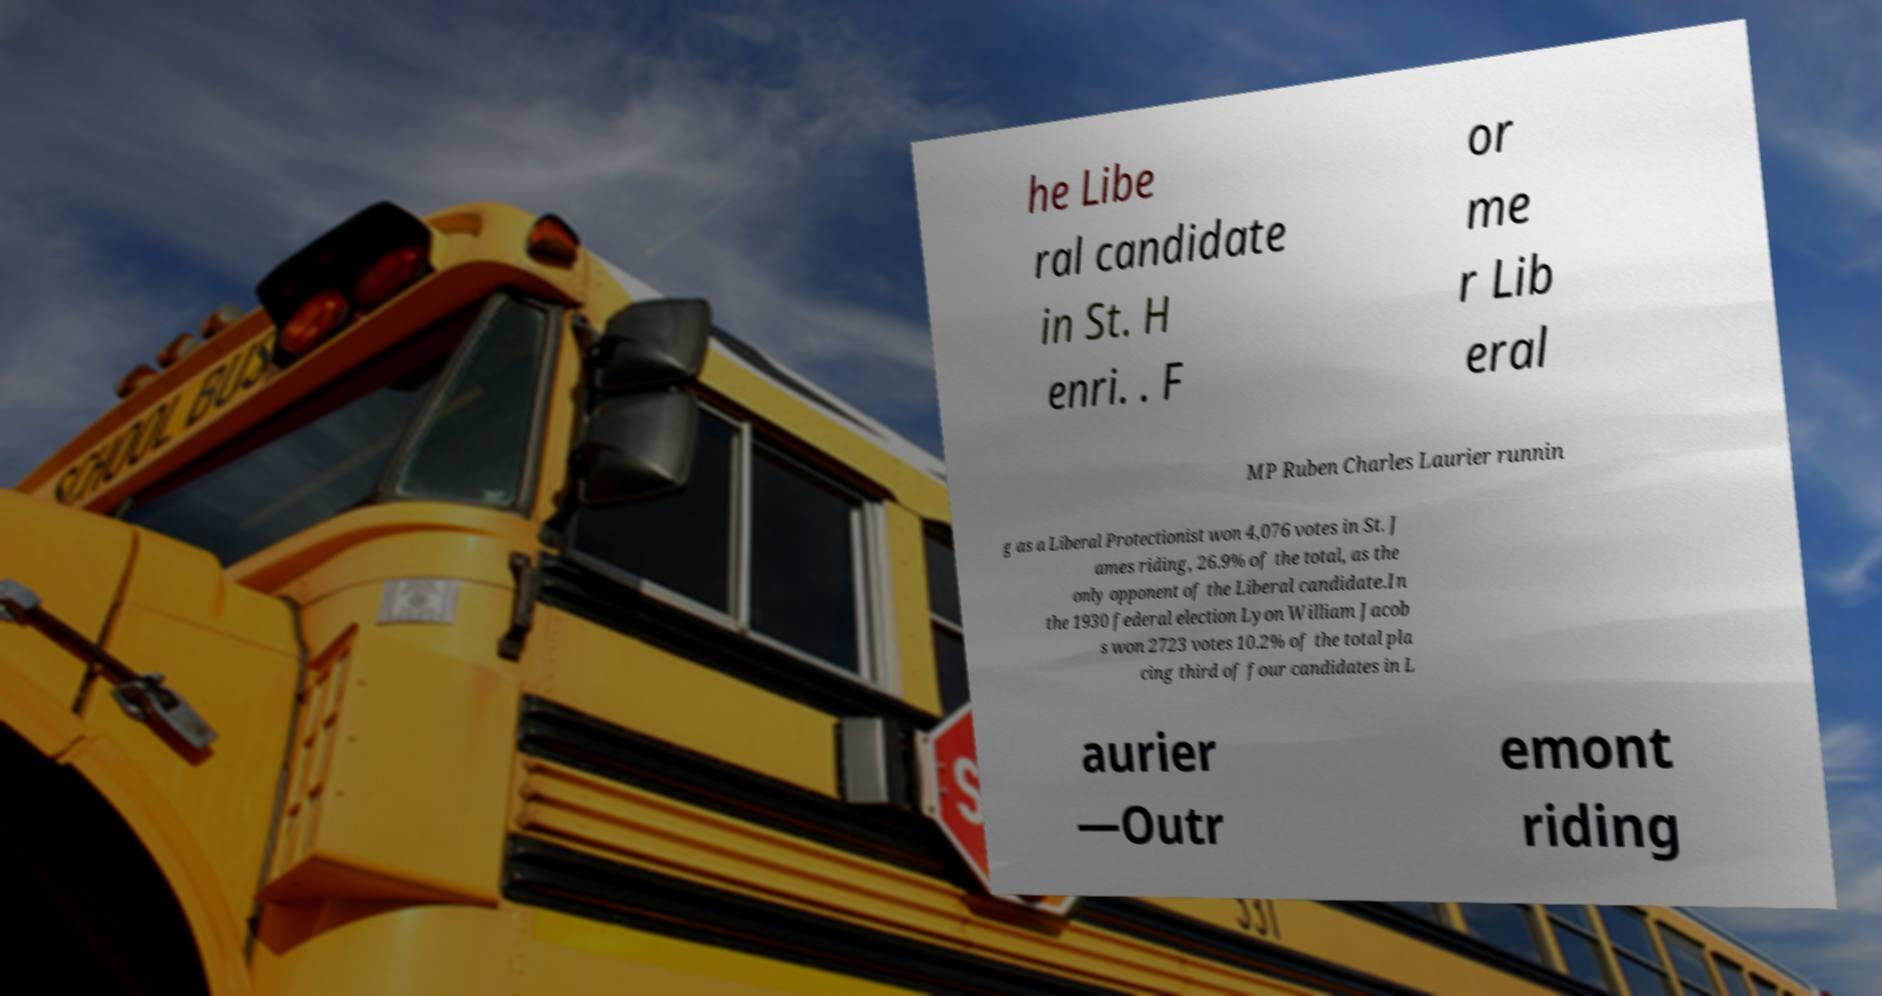There's text embedded in this image that I need extracted. Can you transcribe it verbatim? he Libe ral candidate in St. H enri. . F or me r Lib eral MP Ruben Charles Laurier runnin g as a Liberal Protectionist won 4,076 votes in St. J ames riding, 26.9% of the total, as the only opponent of the Liberal candidate.In the 1930 federal election Lyon William Jacob s won 2723 votes 10.2% of the total pla cing third of four candidates in L aurier —Outr emont riding 